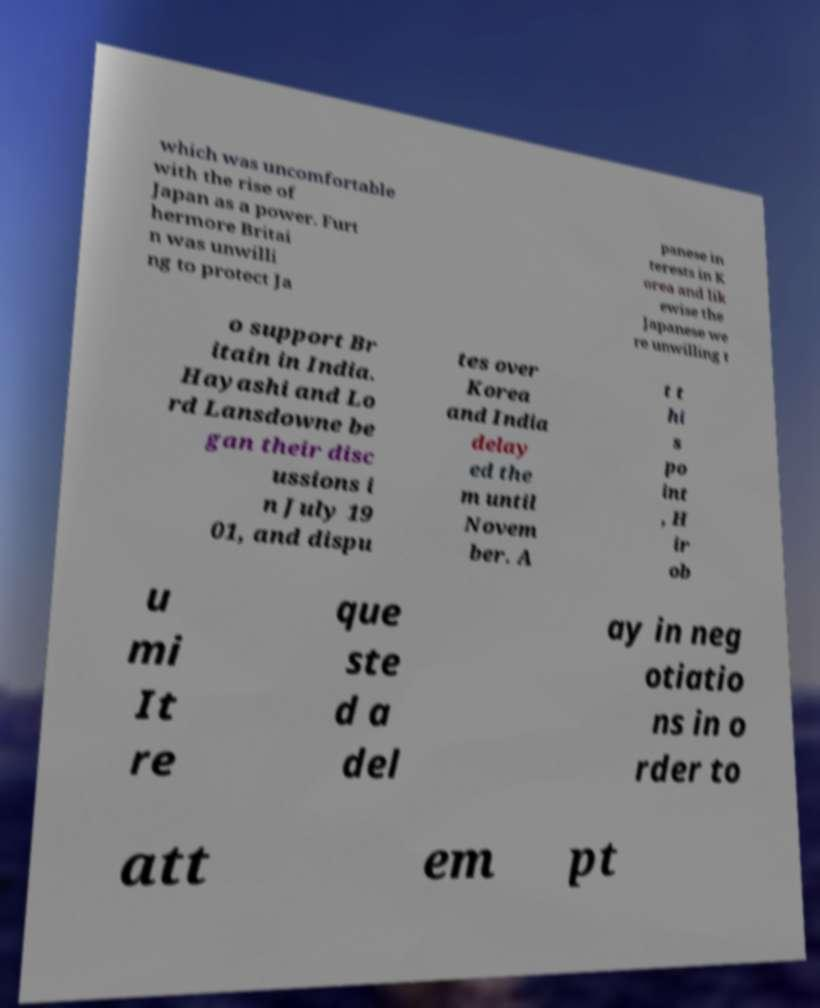Please identify and transcribe the text found in this image. which was uncomfortable with the rise of Japan as a power. Furt hermore Britai n was unwilli ng to protect Ja panese in terests in K orea and lik ewise the Japanese we re unwilling t o support Br itain in India. Hayashi and Lo rd Lansdowne be gan their disc ussions i n July 19 01, and dispu tes over Korea and India delay ed the m until Novem ber. A t t hi s po int , H ir ob u mi It re que ste d a del ay in neg otiatio ns in o rder to att em pt 